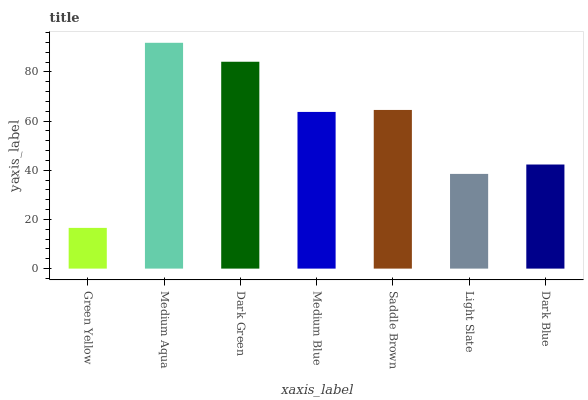Is Green Yellow the minimum?
Answer yes or no. Yes. Is Medium Aqua the maximum?
Answer yes or no. Yes. Is Dark Green the minimum?
Answer yes or no. No. Is Dark Green the maximum?
Answer yes or no. No. Is Medium Aqua greater than Dark Green?
Answer yes or no. Yes. Is Dark Green less than Medium Aqua?
Answer yes or no. Yes. Is Dark Green greater than Medium Aqua?
Answer yes or no. No. Is Medium Aqua less than Dark Green?
Answer yes or no. No. Is Medium Blue the high median?
Answer yes or no. Yes. Is Medium Blue the low median?
Answer yes or no. Yes. Is Saddle Brown the high median?
Answer yes or no. No. Is Green Yellow the low median?
Answer yes or no. No. 